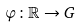Convert formula to latex. <formula><loc_0><loc_0><loc_500><loc_500>\varphi \colon \mathbb { R } \rightarrow G</formula> 